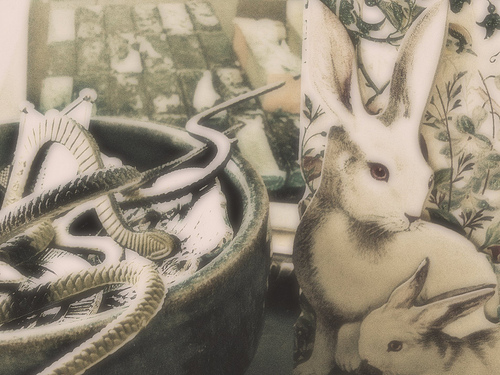<image>
Is there a big rabbit in front of the little rabbit? No. The big rabbit is not in front of the little rabbit. The spatial positioning shows a different relationship between these objects. 